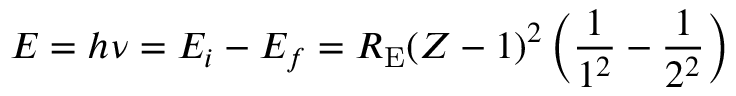Convert formula to latex. <formula><loc_0><loc_0><loc_500><loc_500>E = h \nu = E _ { i } - E _ { f } = R _ { E } ( Z - 1 ) ^ { 2 } \left ( { \frac { 1 } { 1 ^ { 2 } } } - { \frac { 1 } { 2 ^ { 2 } } } \right )</formula> 